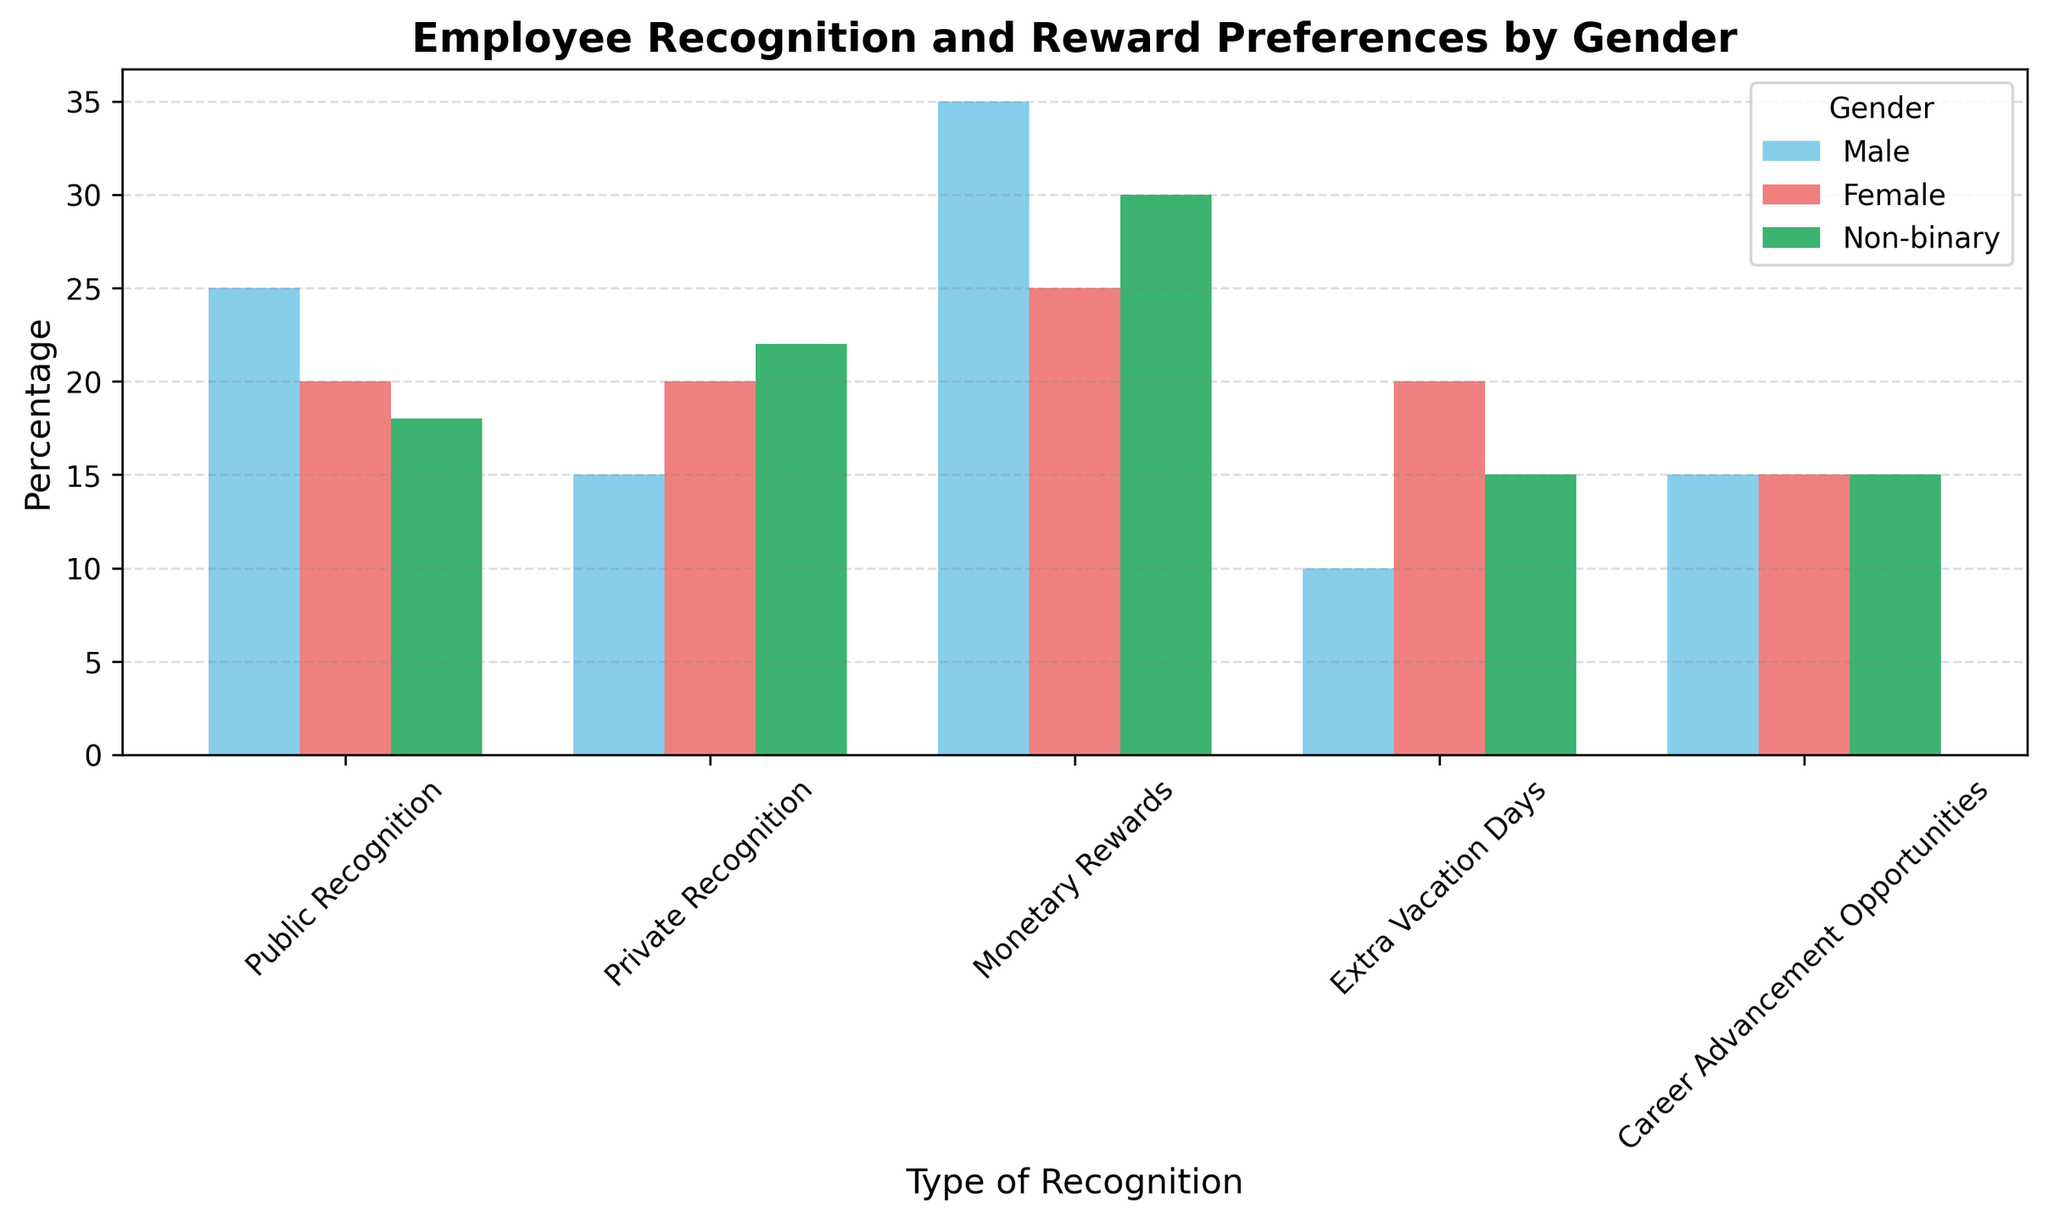What type of recognition is most preferred by Male employees? The bar for Monetary Rewards is the highest among Male employees, indicating it is their most preferred type of recognition.
Answer: Monetary Rewards Which type of recognition has the smallest percentage difference between Male and Female employees? Comparing the percentage differences for each type of recognition: Public Recognition (5%), Private Recognition (5%), Monetary Rewards (10%), Extra Vacation Days (10%), Career Advancement Opportunities (0%). The smallest difference is for Career Advancement Opportunities.
Answer: Career Advancement Opportunities (0%) Which gender prefers Private Recognition the most? The tallest bar for Private Recognition belongs to Non-binary employees, indicating they prefer it the most among the genders.
Answer: Non-binary Sum up the preference percentages for Public Recognition and Monetary Rewards among Female employees. The percentage for Public Recognition is 20% and for Monetary Rewards is 25%. Summing them up: 20% + 25% = 45%.
Answer: 45% Compare the preference for Extra Vacation Days between Female and Non-binary employees. Which one is higher? The bar for Extra Vacation Days is higher for Female employees (20%) compared to Non-binary employees (15%).
Answer: Female Calculate the average preference percentage for Career Advancement Opportunities across all genders. Summing the values for Career Advancement Opportunities: 15% (Male) + 15% (Female) + 15% (Non-binary) = 45%. There are 3 genders, so the average is 45% / 3 = 15%.
Answer: 15% Which type of recognition shows the least variation in preferences across different genders? Looking at the differences between the tallest and shortest bars for each recognition type: Public Recognition (7%), Private Recognition (7%), Monetary Rewards (10%), Extra Vacation Days (10%), Career Advancement Opportunities (0%). Career Advancement Opportunities show the least variation.
Answer: Career Advancement Opportunities (0%) What is the total preference percentage for all types of recognition for Male employees? Adding the percentages for all types of recognition: 25% (Public Recognition) + 15% (Private Recognition) + 35% (Monetary Rewards) + 10% (Extra Vacation Days) + 15% (Career Advancement Opportunities) = 100%.
Answer: 100% Which recognition type do Female employees prefer less than Male employees? Comparing the bars, Private Recognition (20% Female vs. 15% Male), Monetary Rewards (25% Female vs. 35% Male), Extra Vacation Days (20% Female vs. 10% Male), Career Advancement Opportunities are equal. Hence, Female employees prefer Monetary Rewards less than Male employees.
Answer: Monetary Rewards 